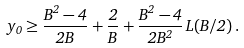Convert formula to latex. <formula><loc_0><loc_0><loc_500><loc_500>y _ { 0 } \geq \frac { B ^ { 2 } - 4 } { 2 B } + \frac { 2 } { B } + \frac { B ^ { 2 } - 4 } { 2 B ^ { 2 } } \, L ( B / 2 ) \, .</formula> 